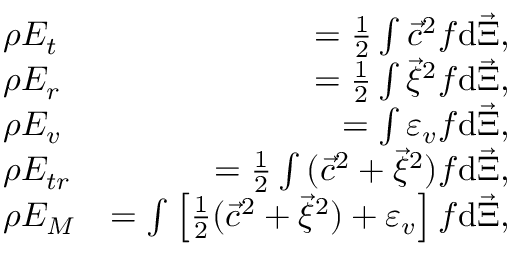Convert formula to latex. <formula><loc_0><loc_0><loc_500><loc_500>\begin{array} { r l r } & { \rho E _ { t } } & { = \frac { 1 } { 2 } \int { { \vec { c } } ^ { 2 } f d { \vec { \Xi } } } , } \\ & { \rho E _ { r } } & { = \frac { 1 } { 2 } \int { { \vec { \xi } } ^ { 2 } f d \vec { \Xi } } , } \\ & { \rho E _ { v } } & { = \int { \varepsilon _ { v } f d \vec { \Xi } } , } \\ & { \rho E _ { t r } } & { = \frac { 1 } { 2 } \int { ( { \vec { c } } ^ { 2 } + { \vec { \xi } } ^ { 2 } ) f d { \vec { \Xi } } } , } \\ & { \rho E _ { M } } & { = \int { \left [ \frac { 1 } { 2 } ( { \vec { c } } ^ { 2 } + \vec { \xi } ^ { 2 } ) + \varepsilon _ { v } \right ] f d \vec { \Xi } } , } \end{array}</formula> 